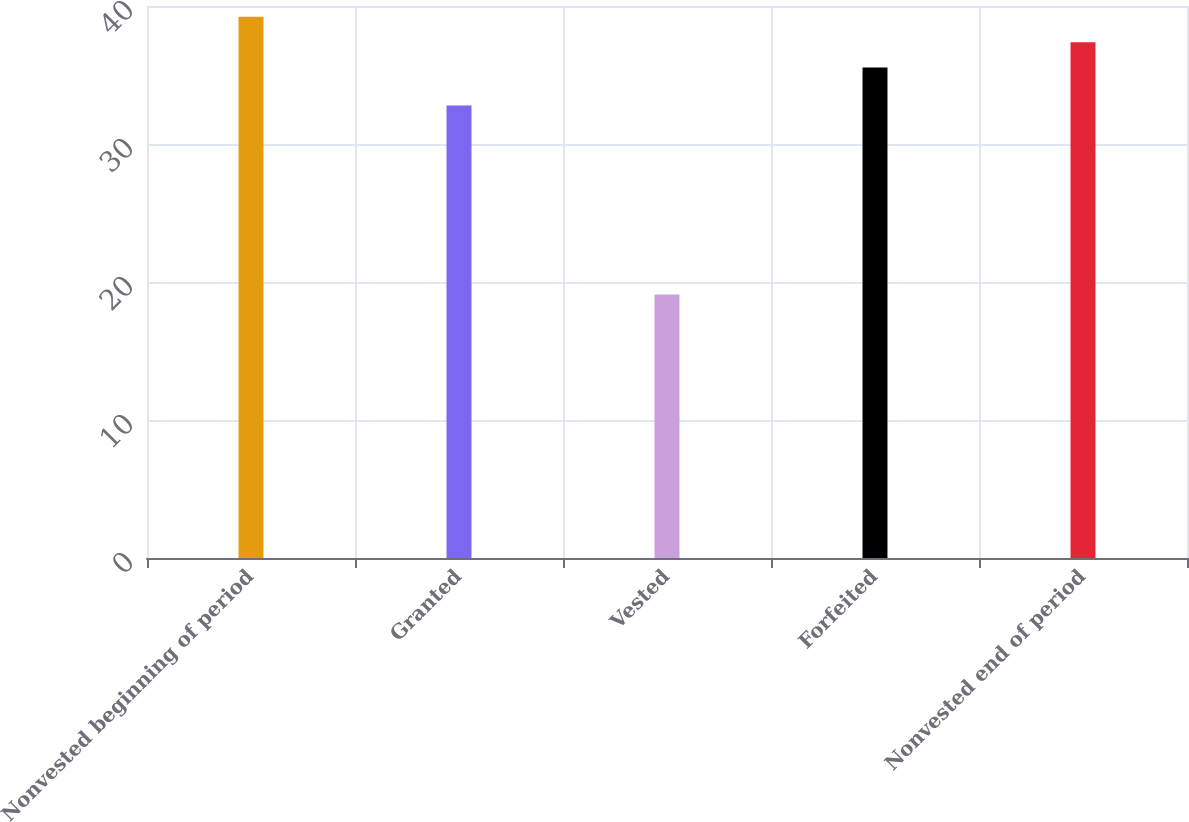<chart> <loc_0><loc_0><loc_500><loc_500><bar_chart><fcel>Nonvested beginning of period<fcel>Granted<fcel>Vested<fcel>Forfeited<fcel>Nonvested end of period<nl><fcel>39.22<fcel>32.79<fcel>19.09<fcel>35.54<fcel>37.38<nl></chart> 